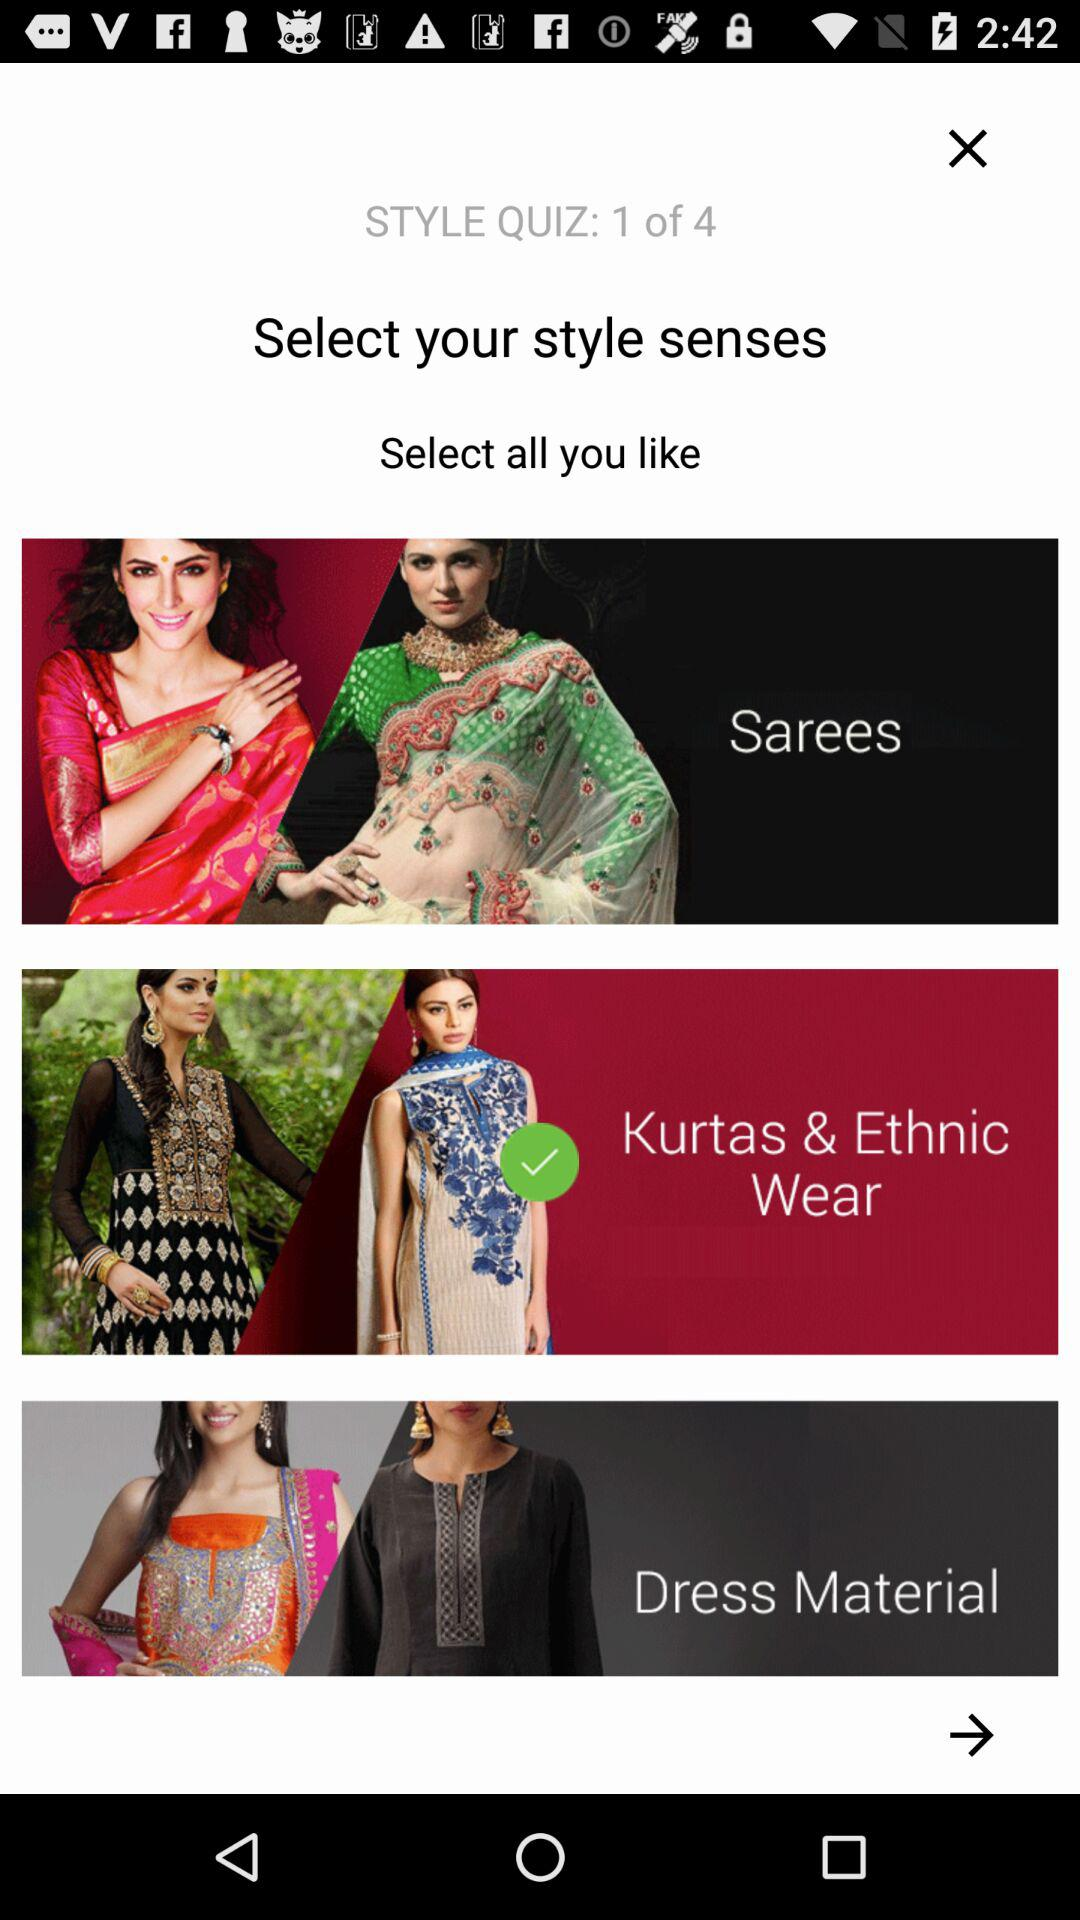What is the selected style? The selected style is "Kurtas & Ethnic Wear". 